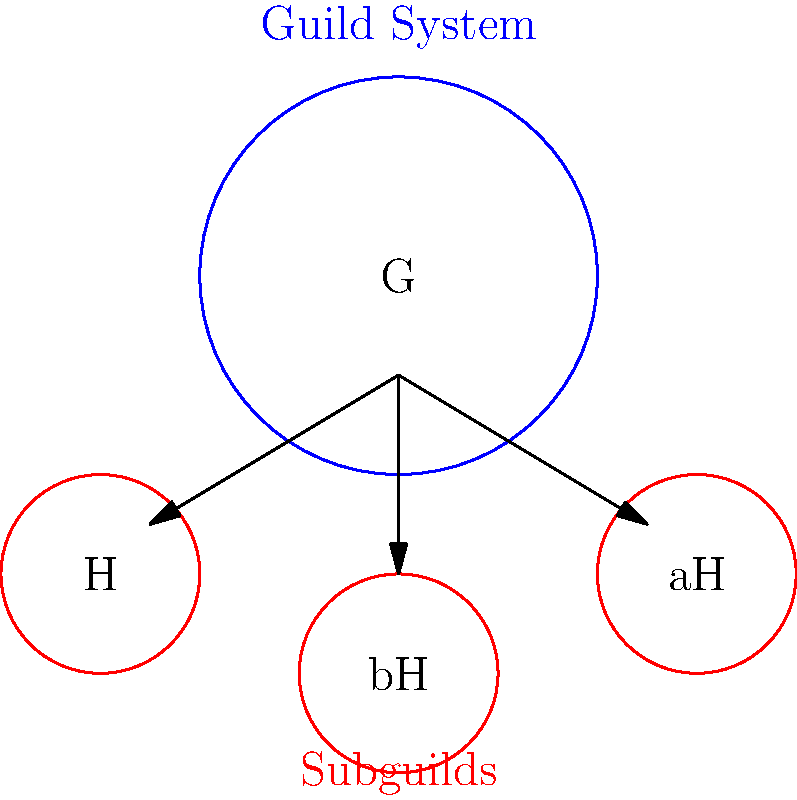In the context of a fantasy game guild system, consider the group $G$ representing the entire guild structure, and its subgroup $H$ representing a specific subguild. If we define the quotient group $G/H$, what would the elements of this quotient group likely represent in terms of the game's guild hierarchy? To understand this concept, let's break it down step-by-step:

1. In group theory, $G$ represents the main group, which in this case is the entire guild system.

2. $H$ is a subgroup of $G$, representing a specific subguild within the larger structure.

3. The quotient group $G/H$ is formed by considering the cosets of $H$ in $G$. Each coset represents a distinct "shift" of the subguild $H$ within the larger guild structure.

4. In the context of a guild system:
   - $H$ would represent the members of a specific subguild
   - $aH$, where $a \in G$, would represent all guild members who are in the same relative position to $H$ as $a$ is

5. Therefore, each element of $G/H$ (i.e., each coset) would represent a distinct "class" or "tier" of subguilds within the larger guild structure.

6. These classes could correspond to different ranks, specializations, or divisions within the guild hierarchy.

7. The number of elements in $G/H$ would indicate how many distinct tiers or classifications exist in the guild system.

In the fantasy game context, this mathematical structure could be used to model complex guild hierarchies, where subguilds might have equivalent roles or ranks despite having different specific members.
Answer: Distinct tiers or classifications of subguilds within the guild hierarchy 